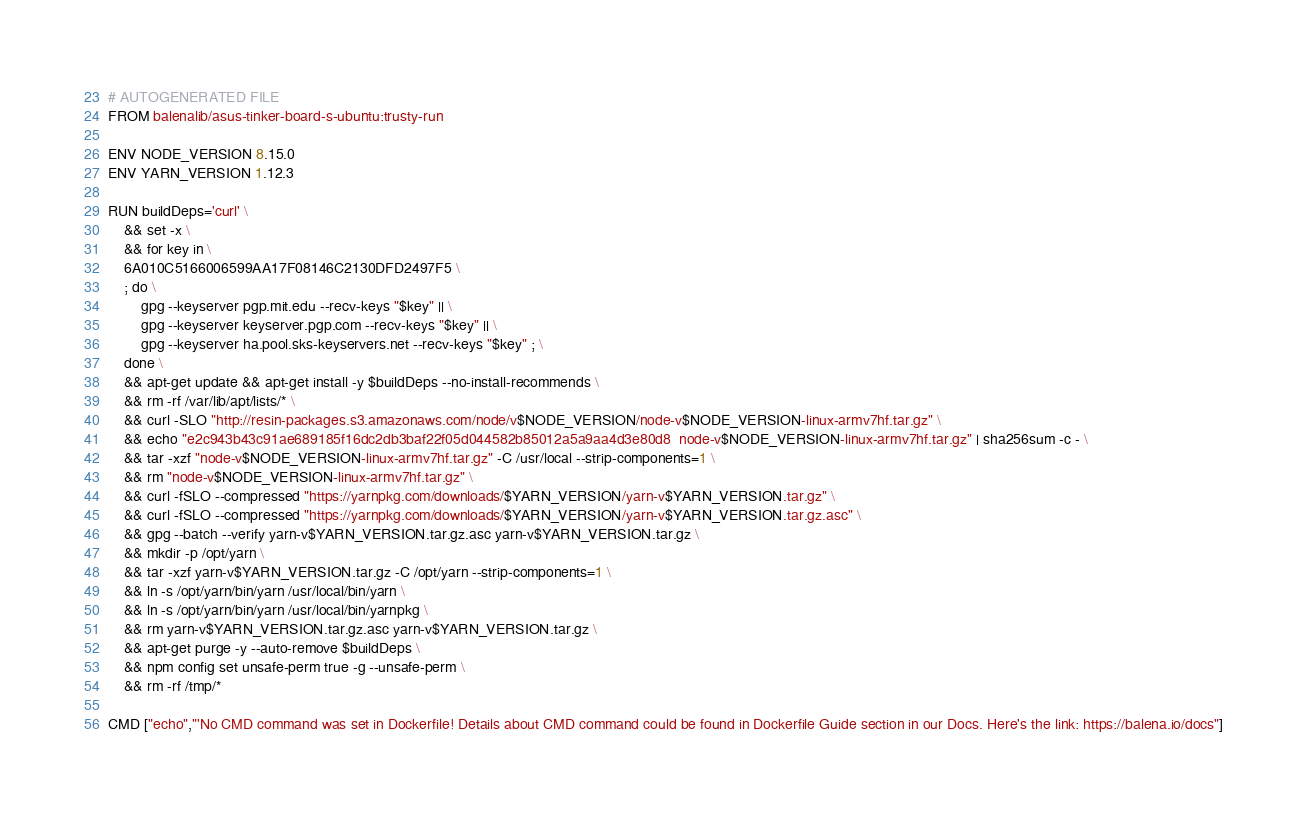Convert code to text. <code><loc_0><loc_0><loc_500><loc_500><_Dockerfile_># AUTOGENERATED FILE
FROM balenalib/asus-tinker-board-s-ubuntu:trusty-run

ENV NODE_VERSION 8.15.0
ENV YARN_VERSION 1.12.3

RUN buildDeps='curl' \
	&& set -x \
	&& for key in \
	6A010C5166006599AA17F08146C2130DFD2497F5 \
	; do \
		gpg --keyserver pgp.mit.edu --recv-keys "$key" || \
		gpg --keyserver keyserver.pgp.com --recv-keys "$key" || \
		gpg --keyserver ha.pool.sks-keyservers.net --recv-keys "$key" ; \
	done \
	&& apt-get update && apt-get install -y $buildDeps --no-install-recommends \
	&& rm -rf /var/lib/apt/lists/* \
	&& curl -SLO "http://resin-packages.s3.amazonaws.com/node/v$NODE_VERSION/node-v$NODE_VERSION-linux-armv7hf.tar.gz" \
	&& echo "e2c943b43c91ae689185f16dc2db3baf22f05d044582b85012a5a9aa4d3e80d8  node-v$NODE_VERSION-linux-armv7hf.tar.gz" | sha256sum -c - \
	&& tar -xzf "node-v$NODE_VERSION-linux-armv7hf.tar.gz" -C /usr/local --strip-components=1 \
	&& rm "node-v$NODE_VERSION-linux-armv7hf.tar.gz" \
	&& curl -fSLO --compressed "https://yarnpkg.com/downloads/$YARN_VERSION/yarn-v$YARN_VERSION.tar.gz" \
	&& curl -fSLO --compressed "https://yarnpkg.com/downloads/$YARN_VERSION/yarn-v$YARN_VERSION.tar.gz.asc" \
	&& gpg --batch --verify yarn-v$YARN_VERSION.tar.gz.asc yarn-v$YARN_VERSION.tar.gz \
	&& mkdir -p /opt/yarn \
	&& tar -xzf yarn-v$YARN_VERSION.tar.gz -C /opt/yarn --strip-components=1 \
	&& ln -s /opt/yarn/bin/yarn /usr/local/bin/yarn \
	&& ln -s /opt/yarn/bin/yarn /usr/local/bin/yarnpkg \
	&& rm yarn-v$YARN_VERSION.tar.gz.asc yarn-v$YARN_VERSION.tar.gz \
	&& apt-get purge -y --auto-remove $buildDeps \
	&& npm config set unsafe-perm true -g --unsafe-perm \
	&& rm -rf /tmp/*

CMD ["echo","'No CMD command was set in Dockerfile! Details about CMD command could be found in Dockerfile Guide section in our Docs. Here's the link: https://balena.io/docs"]</code> 